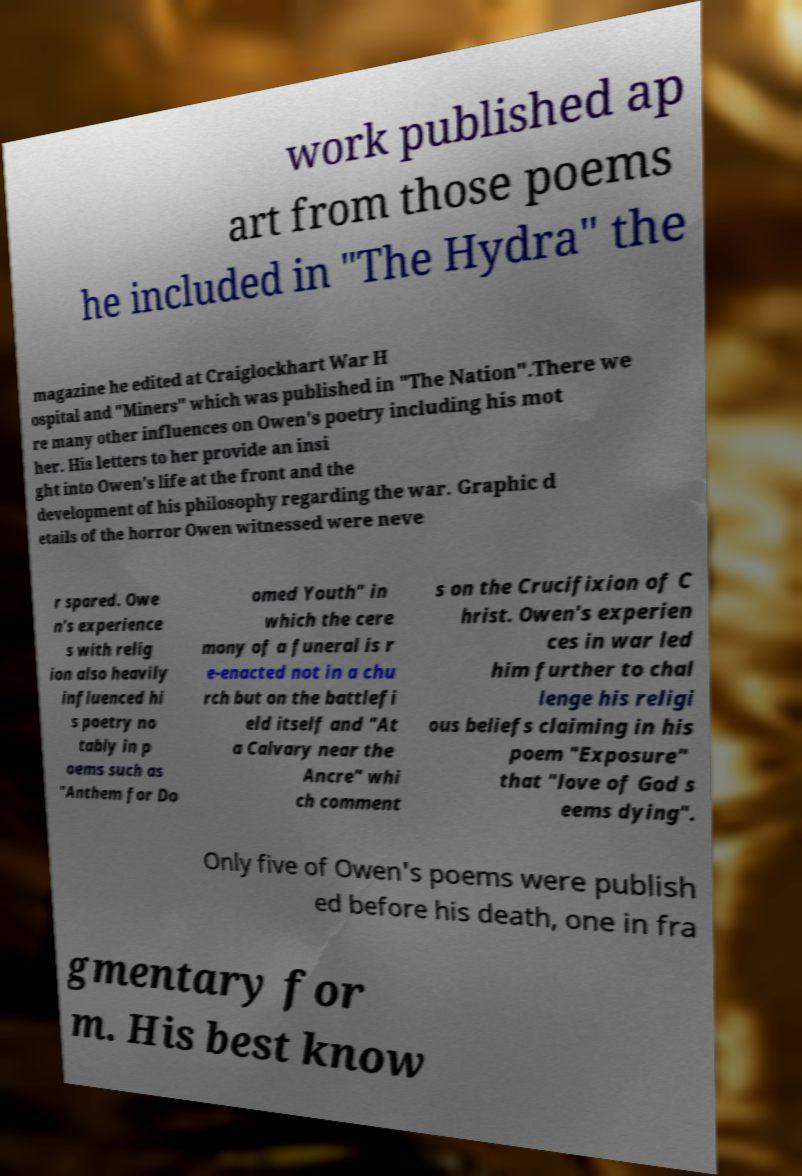Could you assist in decoding the text presented in this image and type it out clearly? work published ap art from those poems he included in "The Hydra" the magazine he edited at Craiglockhart War H ospital and "Miners" which was published in "The Nation".There we re many other influences on Owen's poetry including his mot her. His letters to her provide an insi ght into Owen's life at the front and the development of his philosophy regarding the war. Graphic d etails of the horror Owen witnessed were neve r spared. Owe n's experience s with relig ion also heavily influenced hi s poetry no tably in p oems such as "Anthem for Do omed Youth" in which the cere mony of a funeral is r e-enacted not in a chu rch but on the battlefi eld itself and "At a Calvary near the Ancre" whi ch comment s on the Crucifixion of C hrist. Owen's experien ces in war led him further to chal lenge his religi ous beliefs claiming in his poem "Exposure" that "love of God s eems dying". Only five of Owen's poems were publish ed before his death, one in fra gmentary for m. His best know 